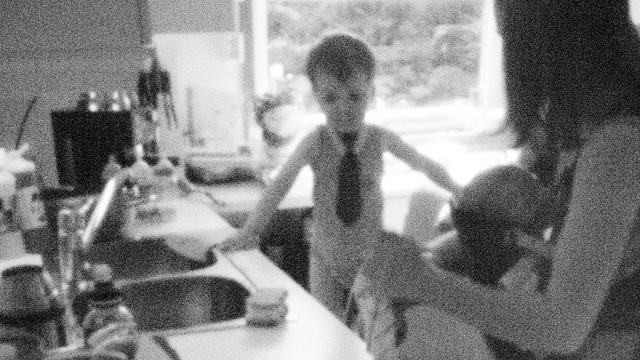How many sinks are in the picture?
Give a very brief answer. 2. How many people are there?
Give a very brief answer. 3. 